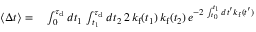<formula> <loc_0><loc_0><loc_500><loc_500>\begin{array} { r l } { \langle \Delta t \rangle = } & \int _ { 0 } ^ { \tau _ { d } } d t _ { 1 } \, \int _ { t _ { 1 } } ^ { \tau _ { d } } d t _ { 2 } \, 2 \, k _ { f } ( t _ { 1 } ) \, k _ { f } ( t _ { 2 } ) \, e ^ { - 2 \, \int _ { t _ { 0 } } ^ { t _ { 1 } } d t ^ { \prime } k _ { f } ( t ^ { \prime } ) } } \end{array}</formula> 